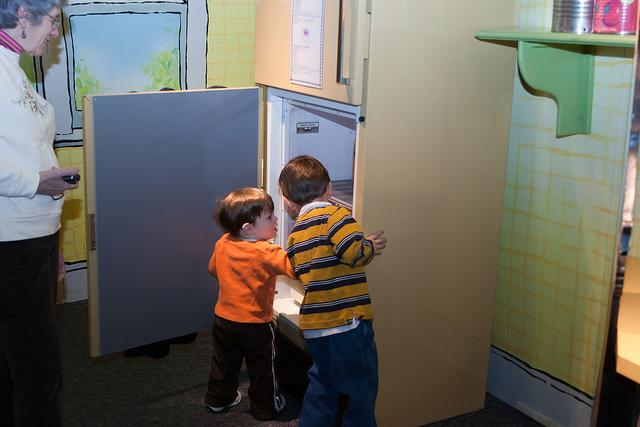The wall decoration and props here are modeled after which location? kitchen 